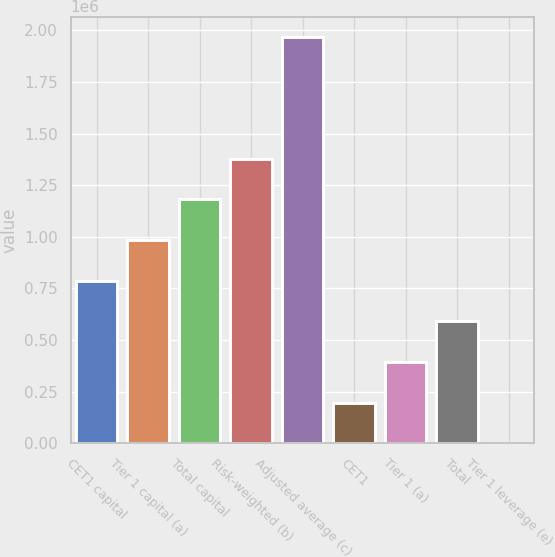Convert chart. <chart><loc_0><loc_0><loc_500><loc_500><bar_chart><fcel>CET1 capital<fcel>Tier 1 capital (a)<fcel>Total capital<fcel>Risk-weighted (b)<fcel>Adjusted average (c)<fcel>CET1<fcel>Tier 1 (a)<fcel>Total<fcel>Tier 1 leverage (e)<nl><fcel>787257<fcel>984070<fcel>1.18088e+06<fcel>1.37769e+06<fcel>1.96813e+06<fcel>196820<fcel>393633<fcel>590445<fcel>8<nl></chart> 